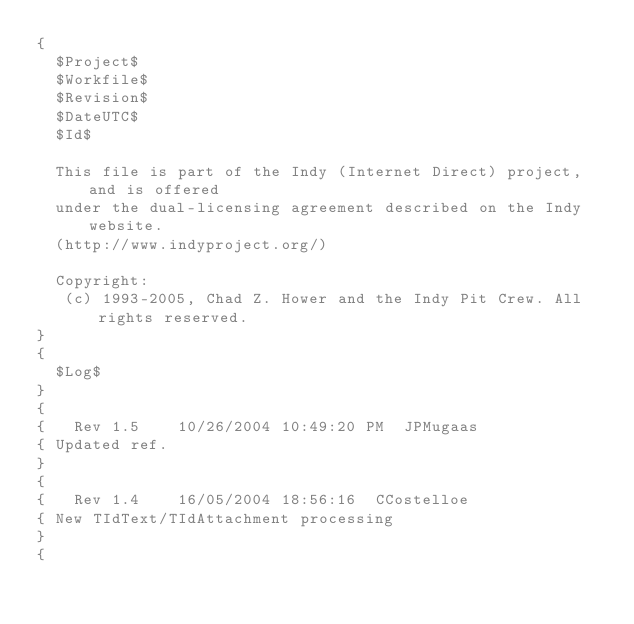<code> <loc_0><loc_0><loc_500><loc_500><_Pascal_>{
  $Project$
  $Workfile$
  $Revision$
  $DateUTC$
  $Id$

  This file is part of the Indy (Internet Direct) project, and is offered
  under the dual-licensing agreement described on the Indy website.
  (http://www.indyproject.org/)

  Copyright:
   (c) 1993-2005, Chad Z. Hower and the Indy Pit Crew. All rights reserved.
}
{
  $Log$
}
{
{   Rev 1.5    10/26/2004 10:49:20 PM  JPMugaas
{ Updated ref.
}
{
{   Rev 1.4    16/05/2004 18:56:16  CCostelloe
{ New TIdText/TIdAttachment processing
}
{</code> 